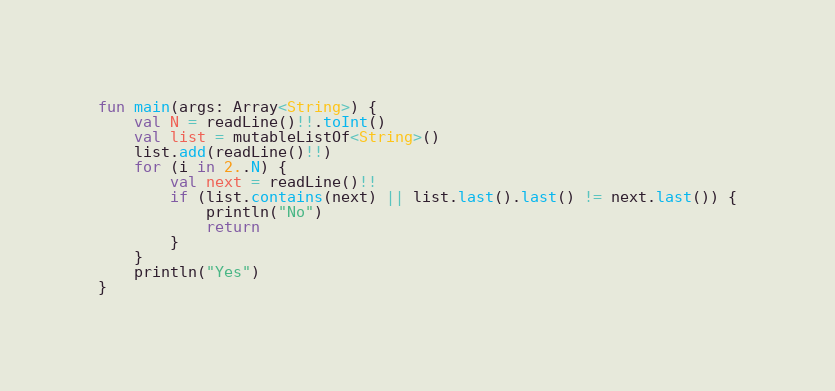<code> <loc_0><loc_0><loc_500><loc_500><_Kotlin_>fun main(args: Array<String>) {
    val N = readLine()!!.toInt()
    val list = mutableListOf<String>()
    list.add(readLine()!!)
    for (i in 2..N) {
        val next = readLine()!!
        if (list.contains(next) || list.last().last() != next.last()) {
            println("No")
            return
        }
    }
    println("Yes")
}</code> 